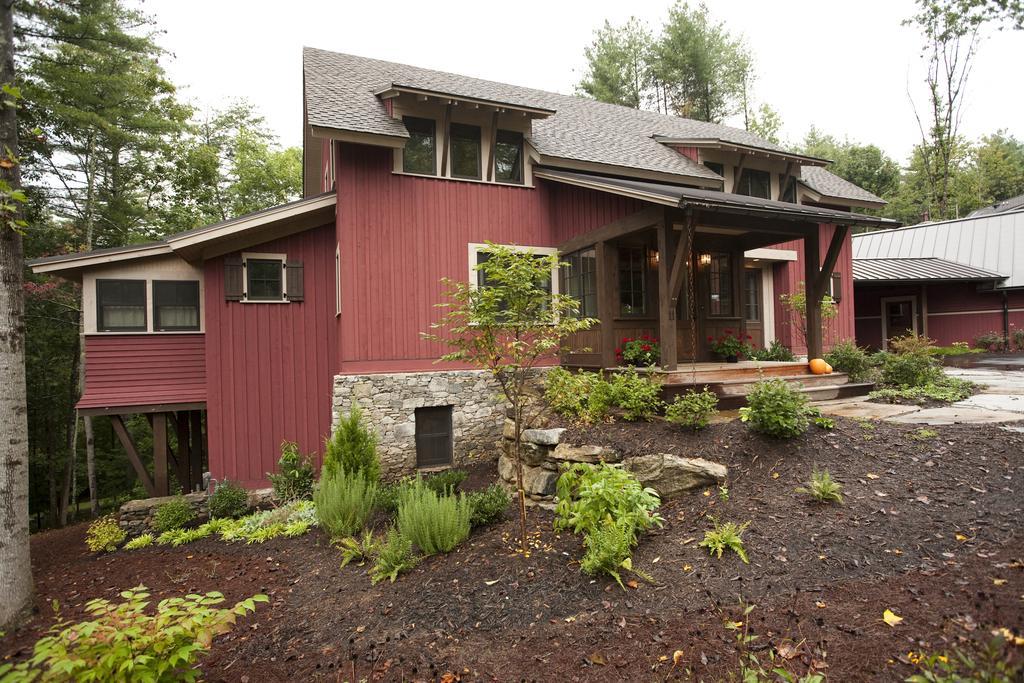Describe this image in one or two sentences. In this image, we can see a shed and in the background, there are trees and we can see some plants. At the bottom, there is ground. 